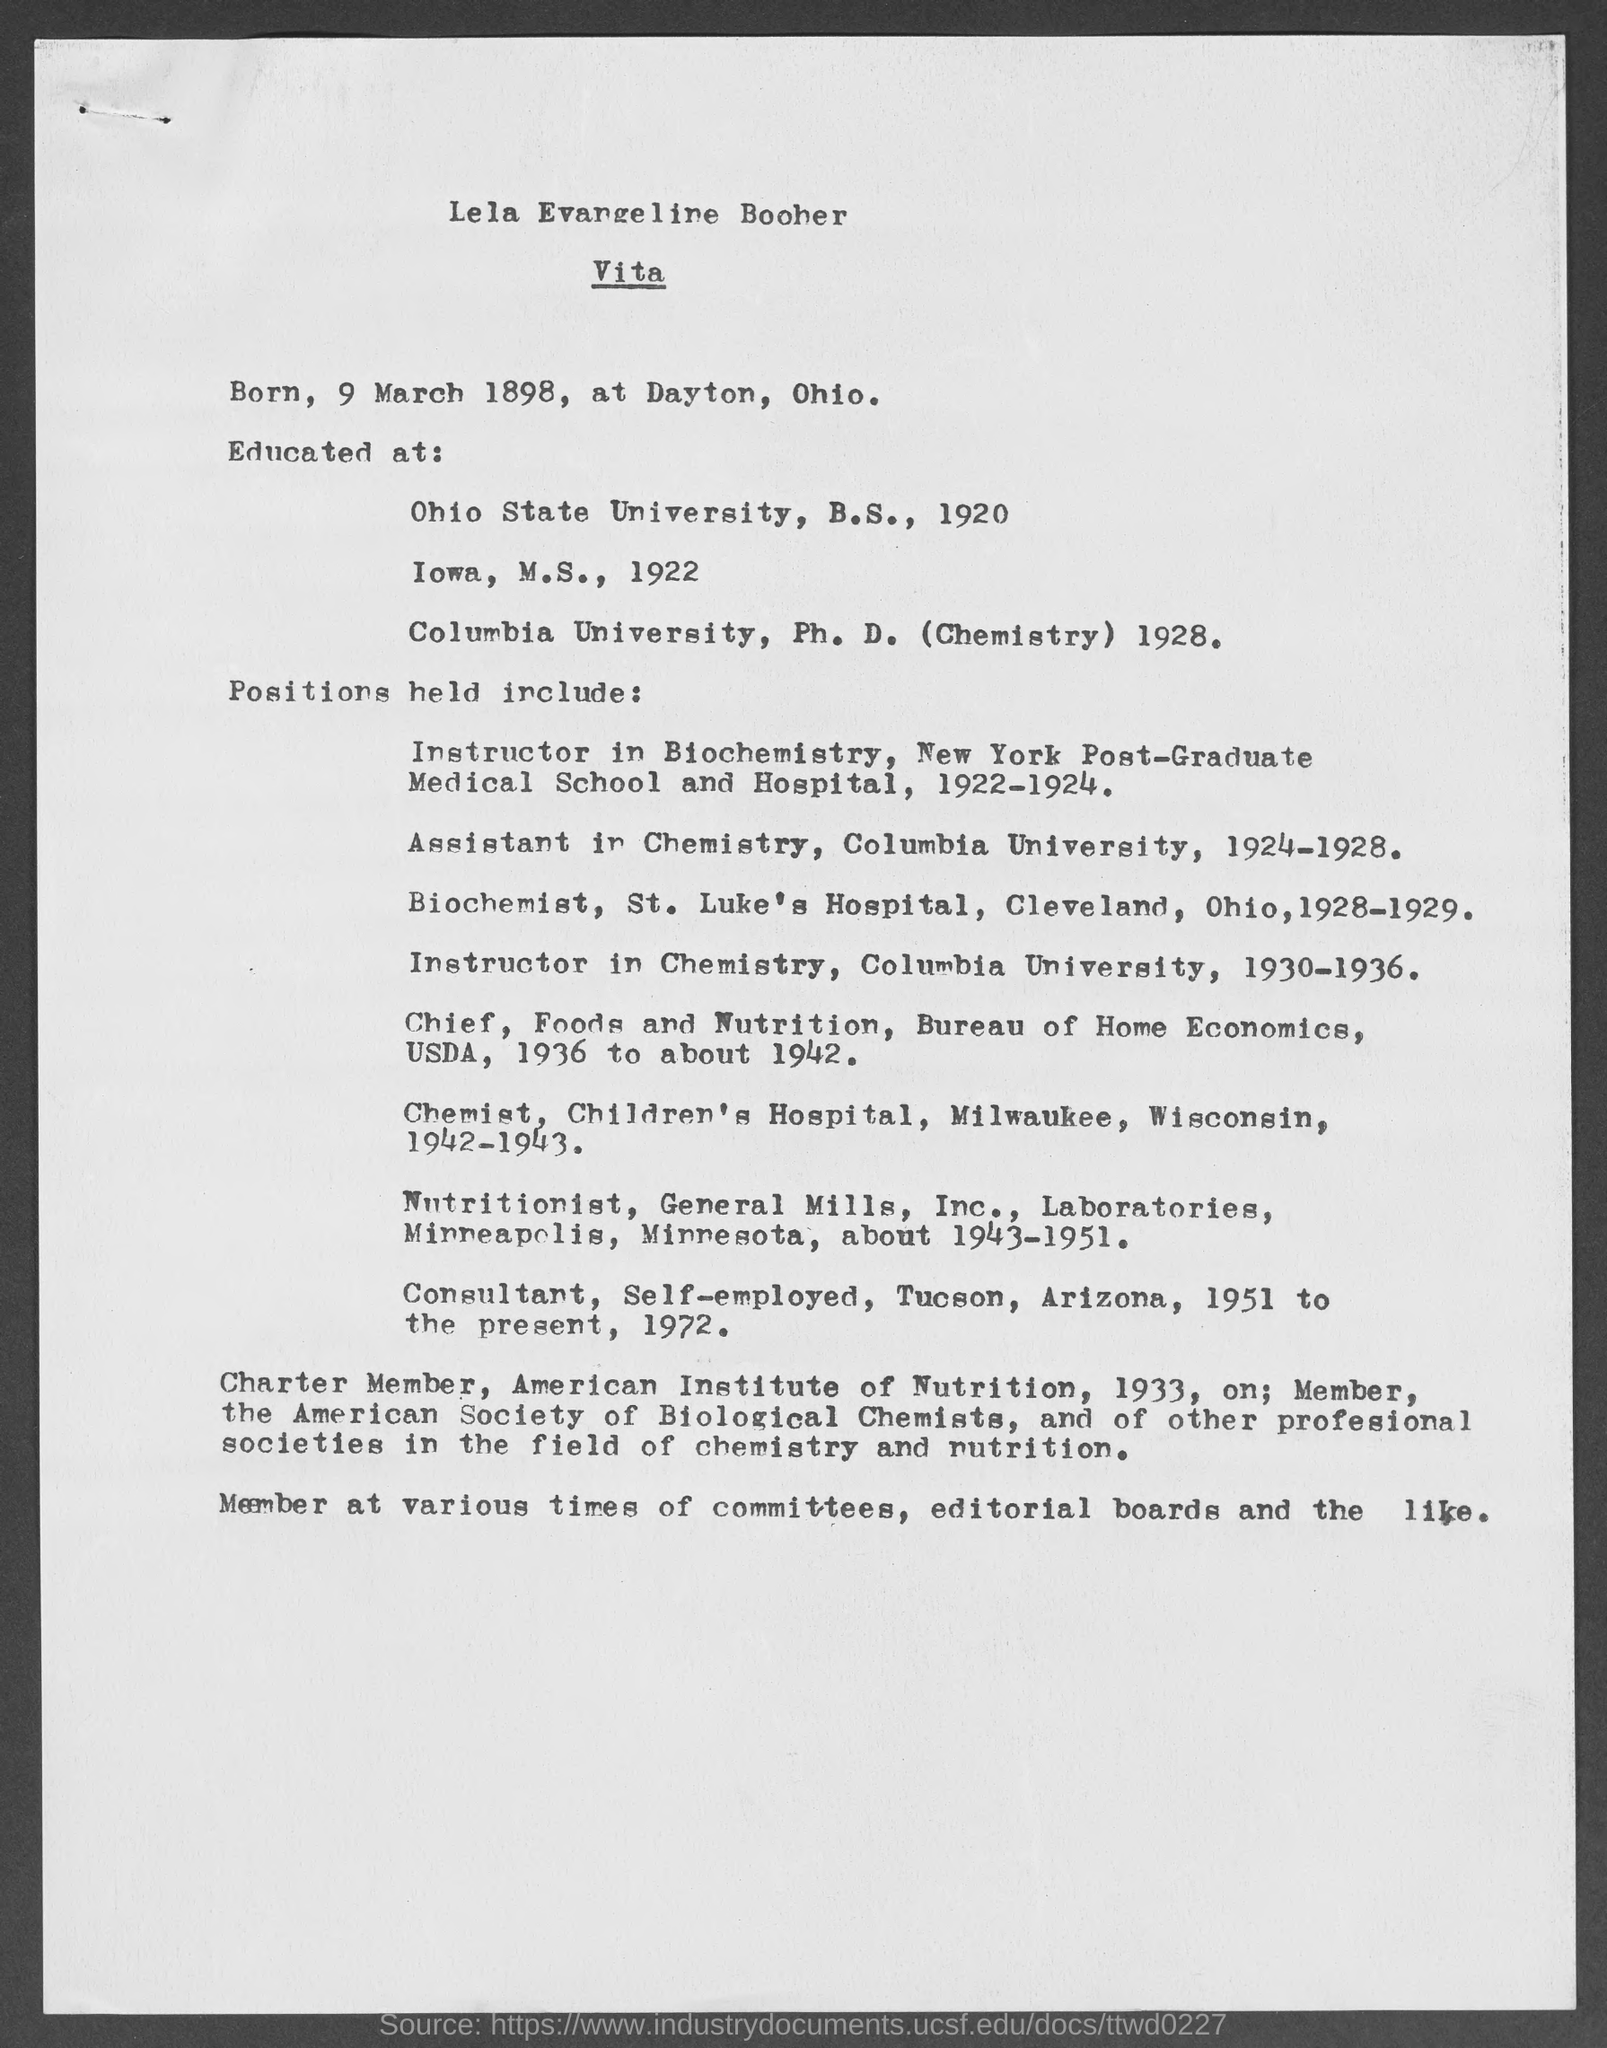Indicate a few pertinent items in this graphic. Lela Evangeline Boober completed her Ph.D. in 1928. Lela Evangeline held the position of Instructor in Biochemistry at the New York Post Graduate Medical School and Hospital from 1922 to 1924. Lela Evangeline Boober earned her Ph.D. in from Columbia University. The date of birth of Lela Evangeline Boober is March 9, 1898. Lela Evangeline Boober completed her Bachelor of Science degree in 1920. 